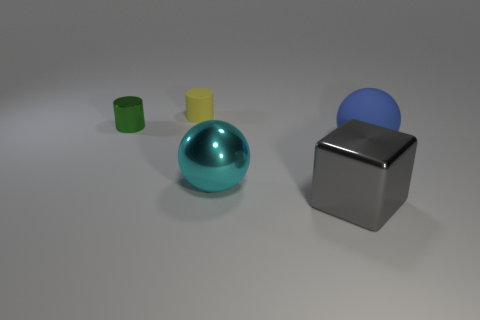There is a big object that is made of the same material as the big cyan ball; what shape is it?
Ensure brevity in your answer.  Cube. What color is the metal ball in front of the rubber thing to the left of the big metal cube?
Offer a very short reply. Cyan. Does the block have the same color as the matte cylinder?
Ensure brevity in your answer.  No. What material is the blue sphere behind the big ball that is to the left of the blue thing?
Give a very brief answer. Rubber. What material is the other object that is the same shape as the small rubber thing?
Ensure brevity in your answer.  Metal. Are there any tiny metal cylinders in front of the metallic object that is to the left of the rubber object to the left of the matte sphere?
Keep it short and to the point. No. How many other things are there of the same color as the big shiny block?
Your answer should be compact. 0. How many objects are both in front of the big blue rubber sphere and behind the tiny metallic object?
Your answer should be compact. 0. The large gray object has what shape?
Your answer should be very brief. Cube. How many other objects are there of the same material as the blue object?
Make the answer very short. 1. 